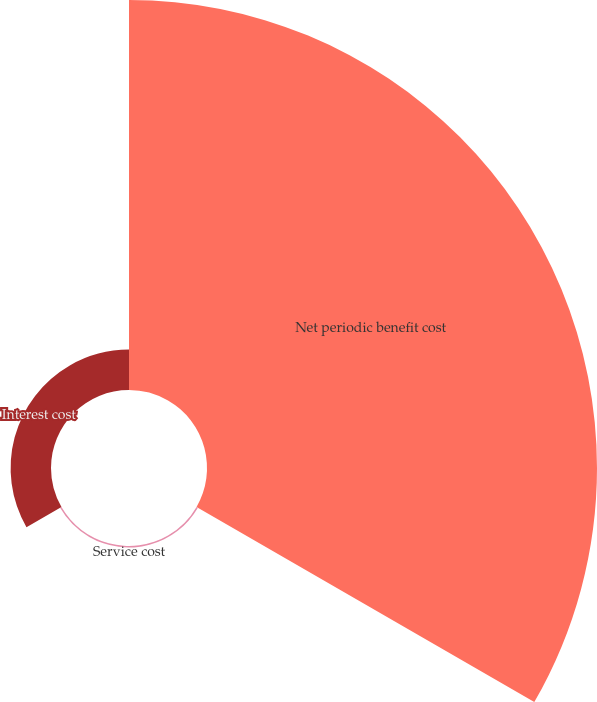Convert chart to OTSL. <chart><loc_0><loc_0><loc_500><loc_500><pie_chart><fcel>Net periodic benefit cost<fcel>Service cost<fcel>Interest cost<nl><fcel>90.29%<fcel>0.36%<fcel>9.35%<nl></chart> 